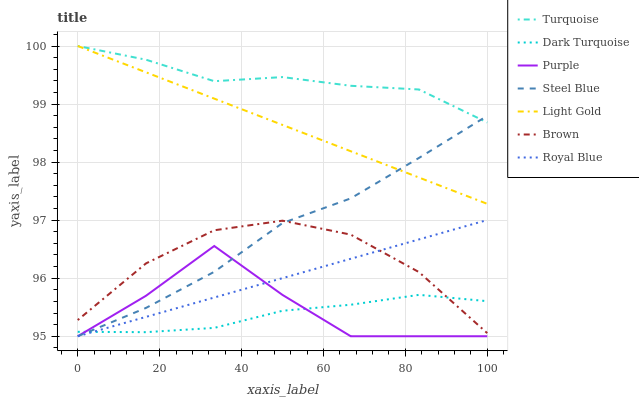Does Dark Turquoise have the minimum area under the curve?
Answer yes or no. Yes. Does Turquoise have the maximum area under the curve?
Answer yes or no. Yes. Does Purple have the minimum area under the curve?
Answer yes or no. No. Does Purple have the maximum area under the curve?
Answer yes or no. No. Is Light Gold the smoothest?
Answer yes or no. Yes. Is Purple the roughest?
Answer yes or no. Yes. Is Turquoise the smoothest?
Answer yes or no. No. Is Turquoise the roughest?
Answer yes or no. No. Does Purple have the lowest value?
Answer yes or no. Yes. Does Turquoise have the lowest value?
Answer yes or no. No. Does Light Gold have the highest value?
Answer yes or no. Yes. Does Purple have the highest value?
Answer yes or no. No. Is Purple less than Turquoise?
Answer yes or no. Yes. Is Brown greater than Purple?
Answer yes or no. Yes. Does Dark Turquoise intersect Steel Blue?
Answer yes or no. Yes. Is Dark Turquoise less than Steel Blue?
Answer yes or no. No. Is Dark Turquoise greater than Steel Blue?
Answer yes or no. No. Does Purple intersect Turquoise?
Answer yes or no. No. 